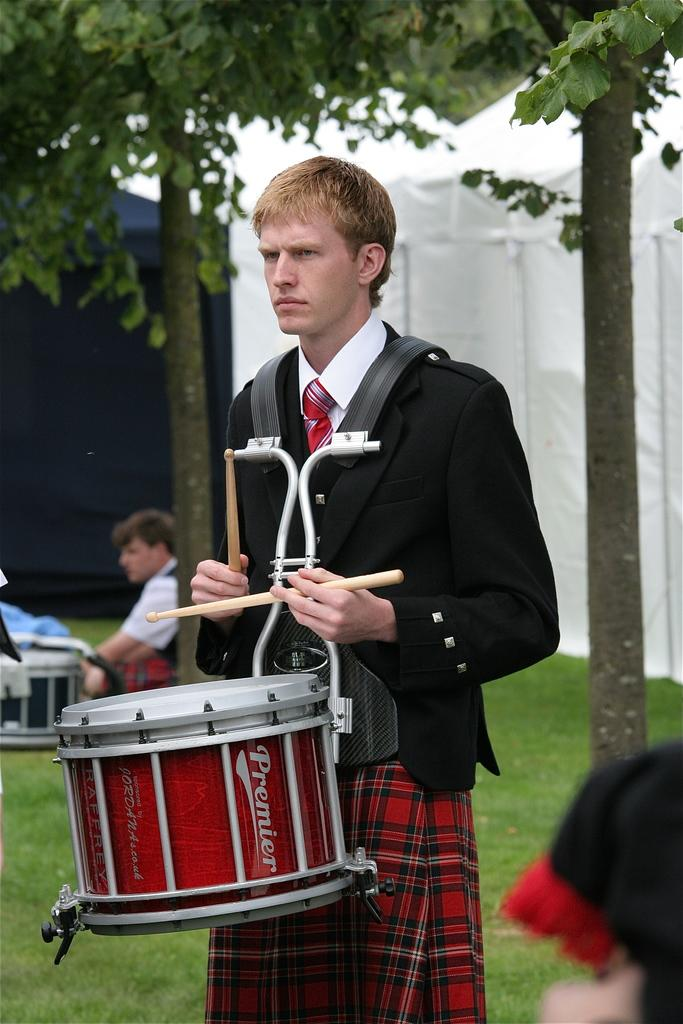What is the main activity being performed by the person in the image? There is a person playing a drum in the image. What color tint can be observed in the background of the image? There is a white color tint in the background of the image. What type of natural scenery is visible in the background of the image? There are trees in the background of the image. What are the people in the background of the image doing? There are people sitting on the grass in the background of the image. How many people are swimming in the image? There is no swimming activity depicted in the image. What type of butter is being used by the person playing the drum? There is no butter present in the image. 